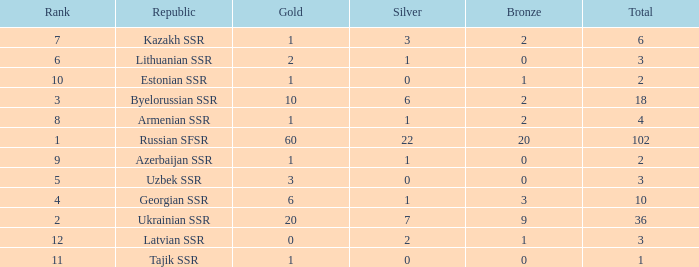What is the total number of bronzes associated with 1 silver, ranks under 6 and under 6 golds? None. 